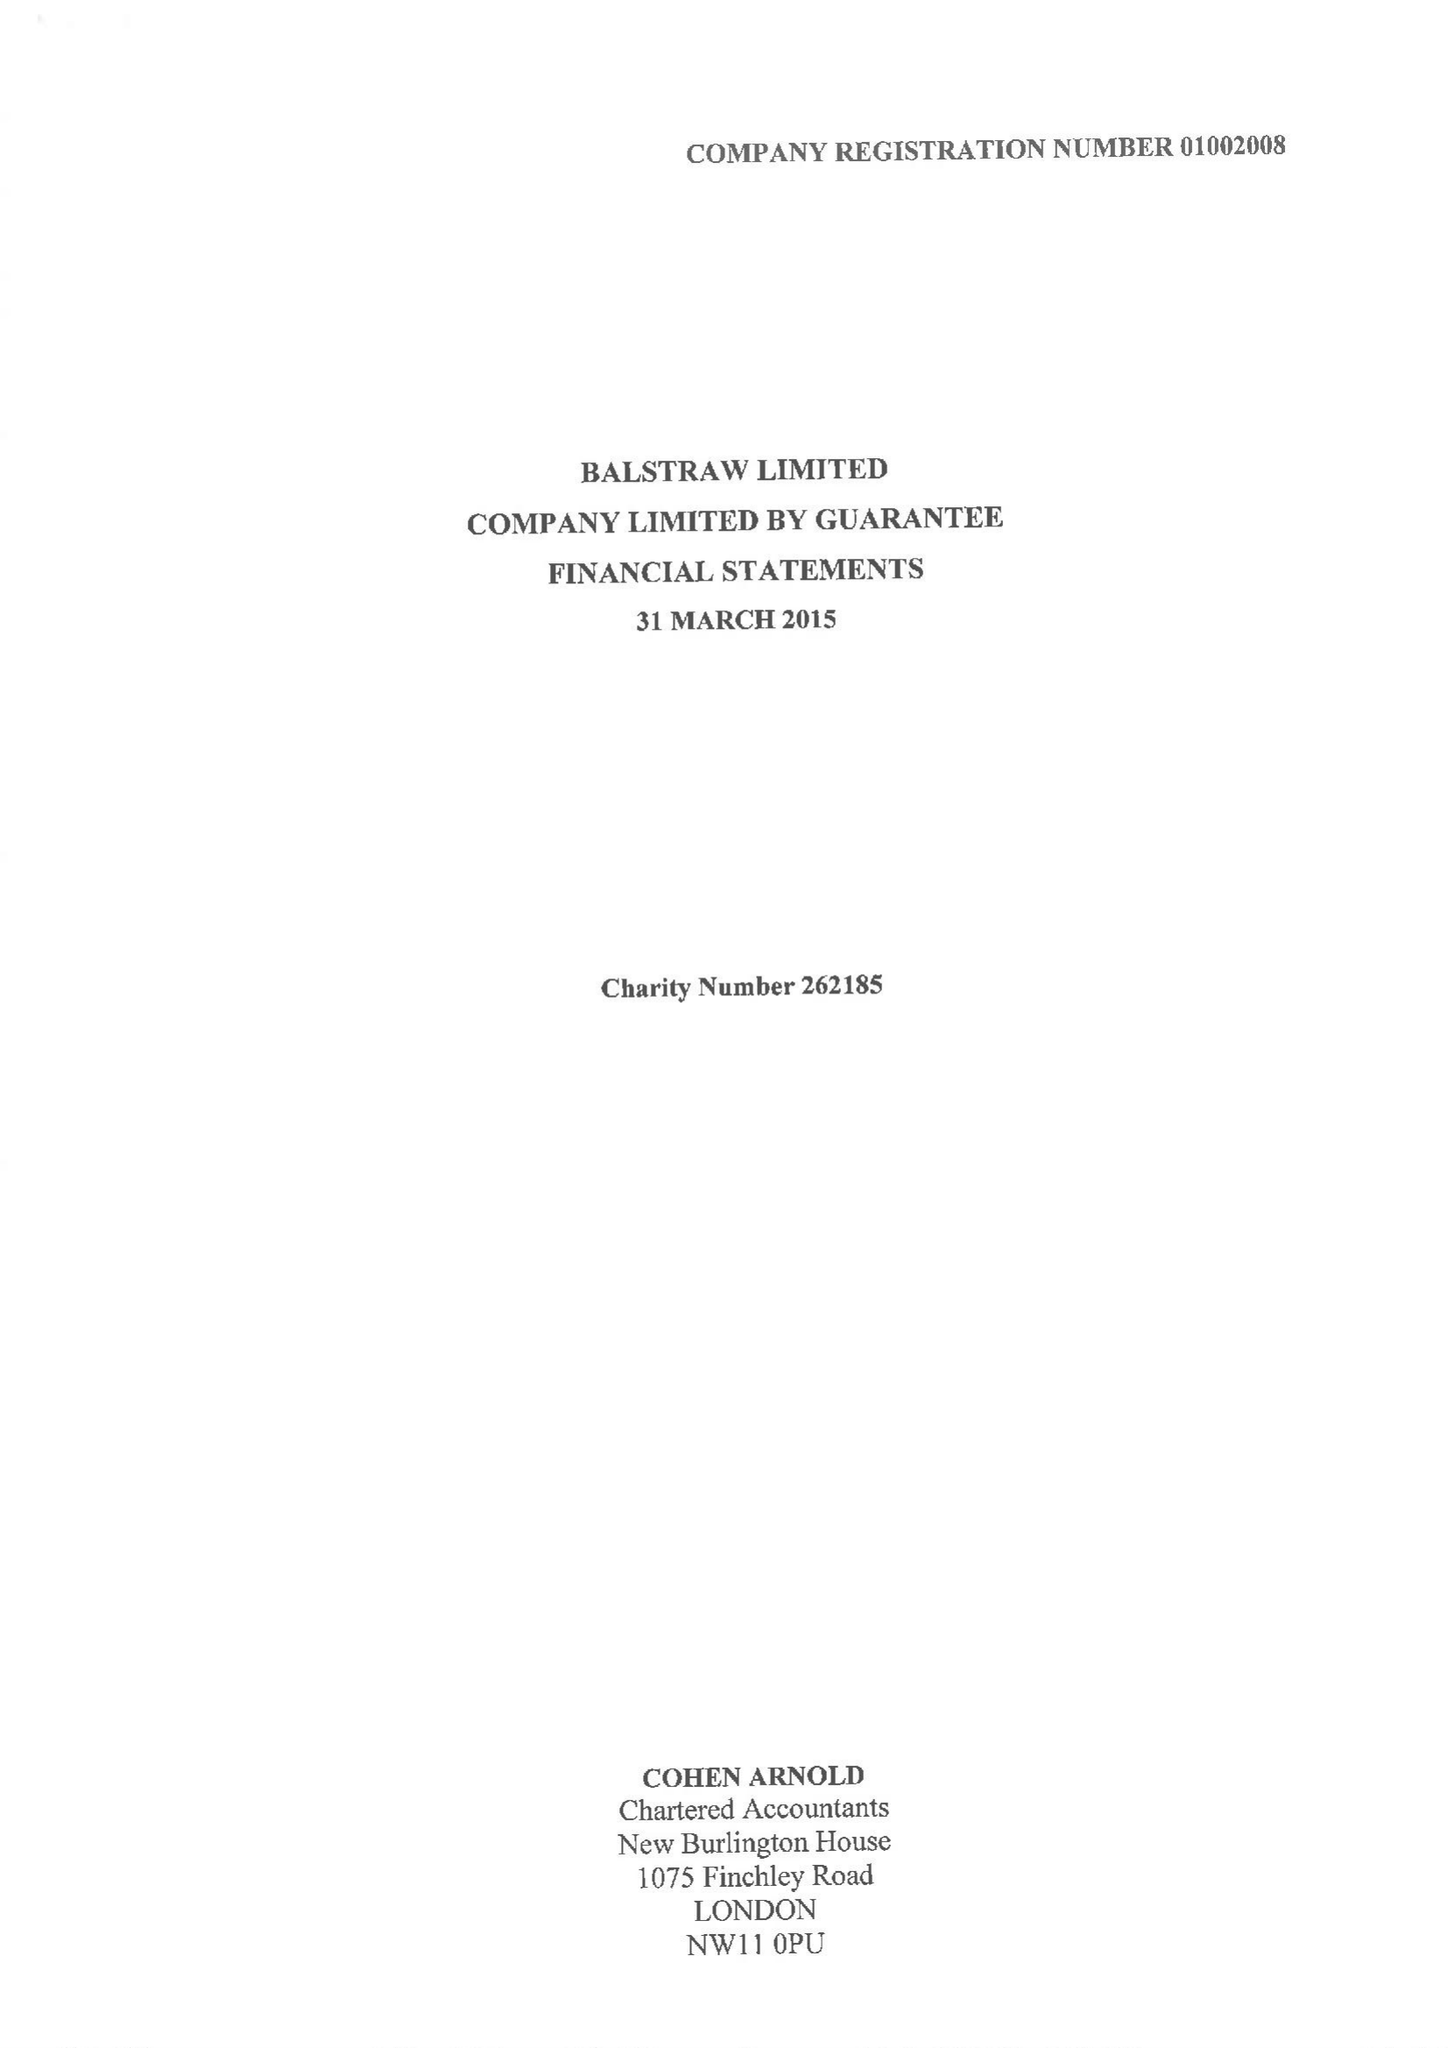What is the value for the address__post_town?
Answer the question using a single word or phrase. LONDON 